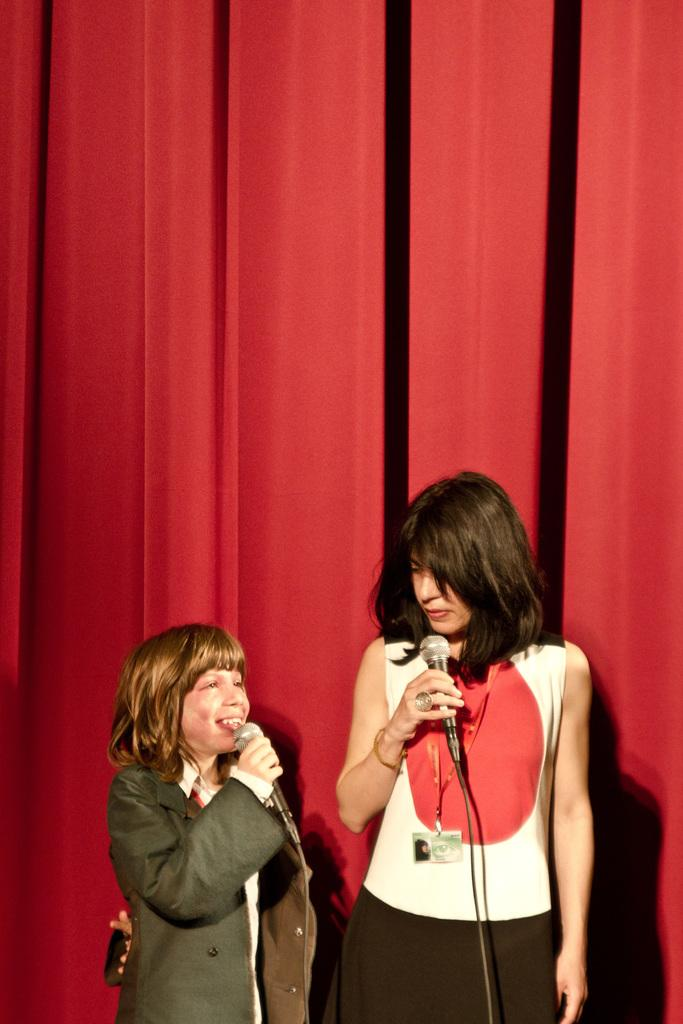What color is the curtain in the background of the image? The curtain in the background of the image is red. Who are the people in the image? There is a woman and a girl in the image. What is the girl holding in her hand? The girl is holding a mic in her hand. What is the girl doing in the image? The girl is talking. What type of animal can be seen playing in the sand in the image? There is no animal playing in the sand in the image. How are the people in the image sorting the objects on the table? There is no table or objects to sort in the image; the girl is holding a mic and talking. 